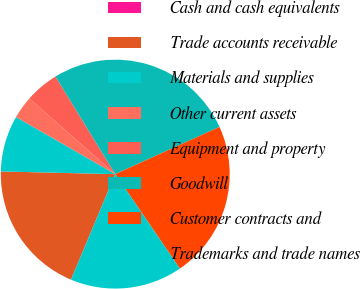Convert chart to OTSL. <chart><loc_0><loc_0><loc_500><loc_500><pie_chart><fcel>Cash and cash equivalents<fcel>Trade accounts receivable<fcel>Materials and supplies<fcel>Other current assets<fcel>Equipment and property<fcel>Goodwill<fcel>Customer contracts and<fcel>Trademarks and trade names<nl><fcel>0.0%<fcel>19.05%<fcel>7.94%<fcel>3.18%<fcel>4.76%<fcel>26.98%<fcel>22.22%<fcel>15.87%<nl></chart> 